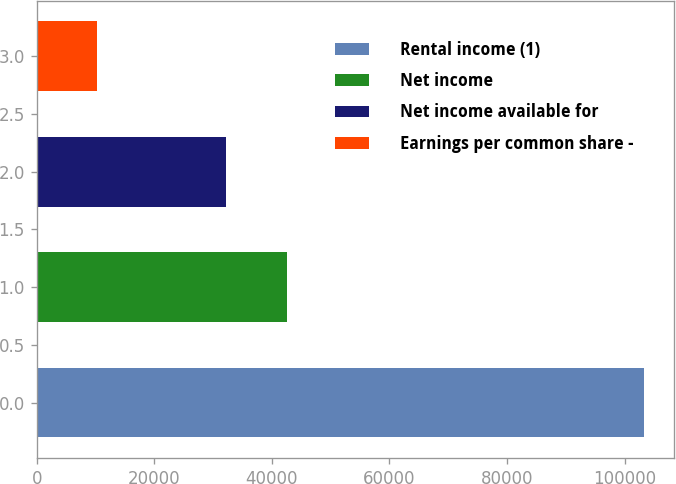<chart> <loc_0><loc_0><loc_500><loc_500><bar_chart><fcel>Rental income (1)<fcel>Net income<fcel>Net income available for<fcel>Earnings per common share -<nl><fcel>103231<fcel>42583<fcel>32260<fcel>10323.6<nl></chart> 